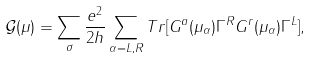Convert formula to latex. <formula><loc_0><loc_0><loc_500><loc_500>\mathcal { G } ( \mu ) = \sum _ { \sigma } \frac { e ^ { 2 } } { 2 h } \sum _ { \alpha = L , R } T r [ G ^ { a } ( \mu _ { \alpha } ) \Gamma ^ { R } G ^ { r } ( \mu _ { \alpha } ) \Gamma ^ { L } ] ,</formula> 